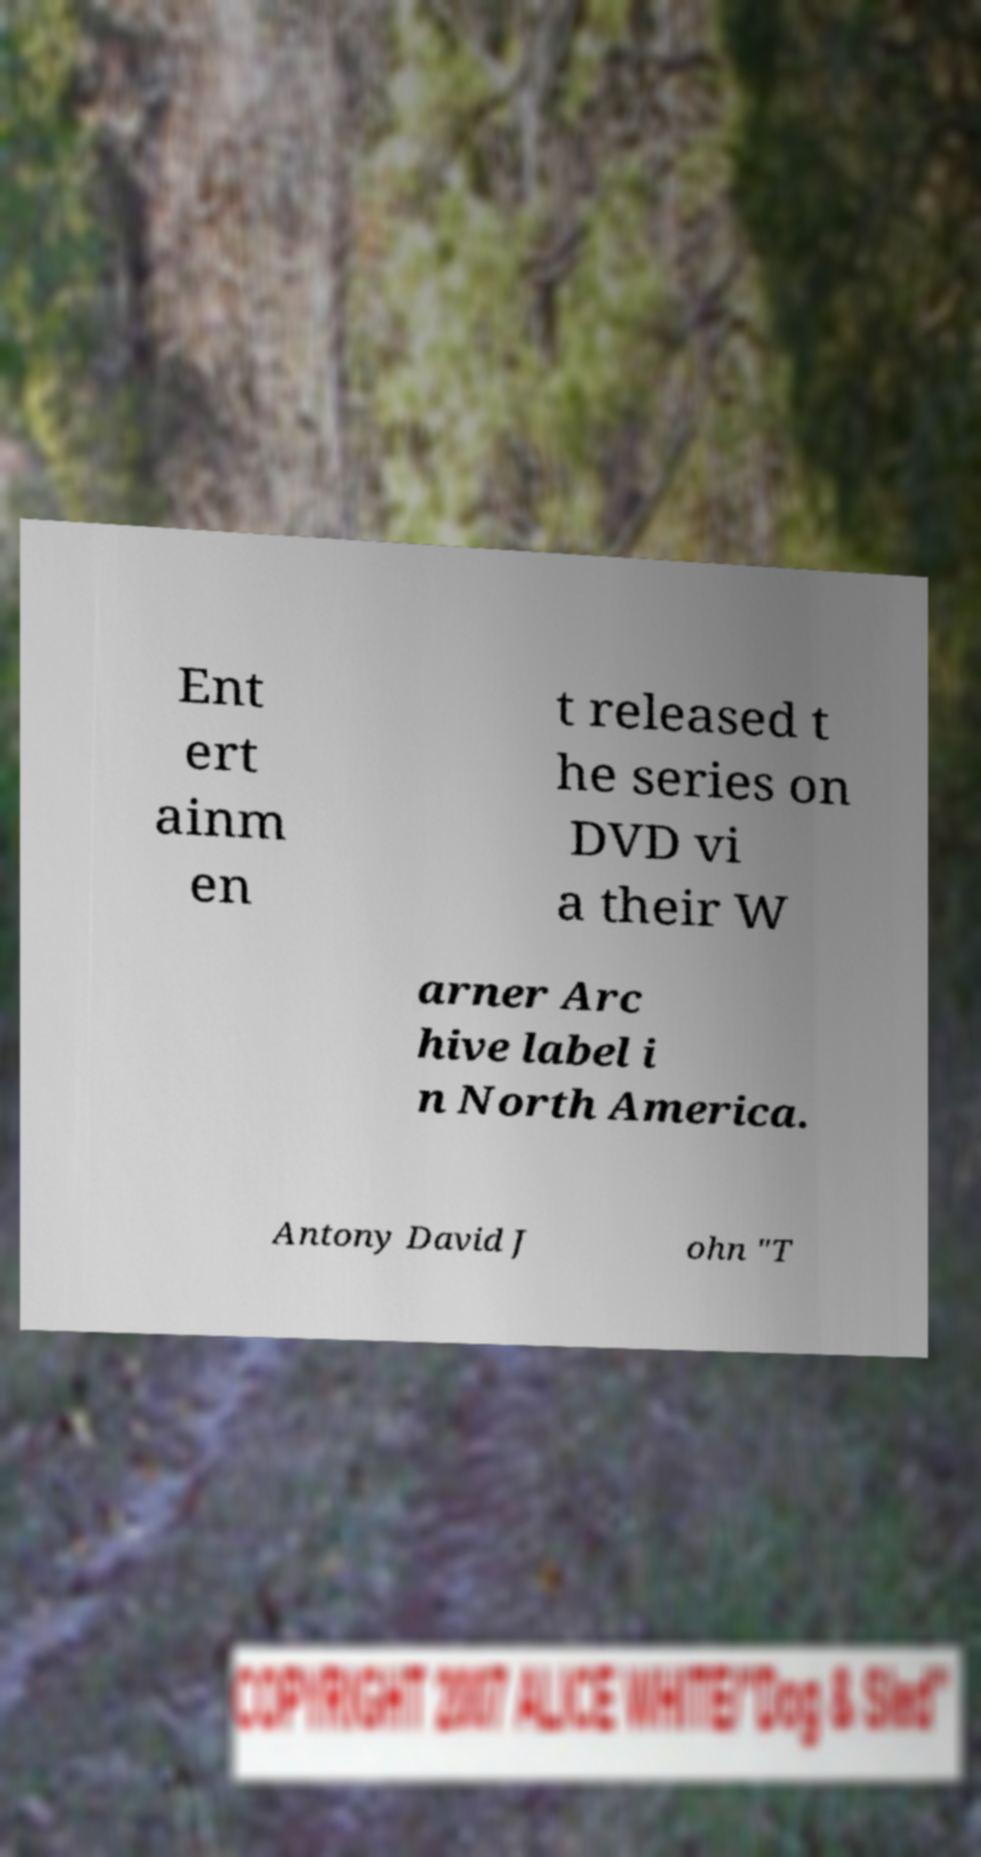I need the written content from this picture converted into text. Can you do that? Ent ert ainm en t released t he series on DVD vi a their W arner Arc hive label i n North America. Antony David J ohn "T 